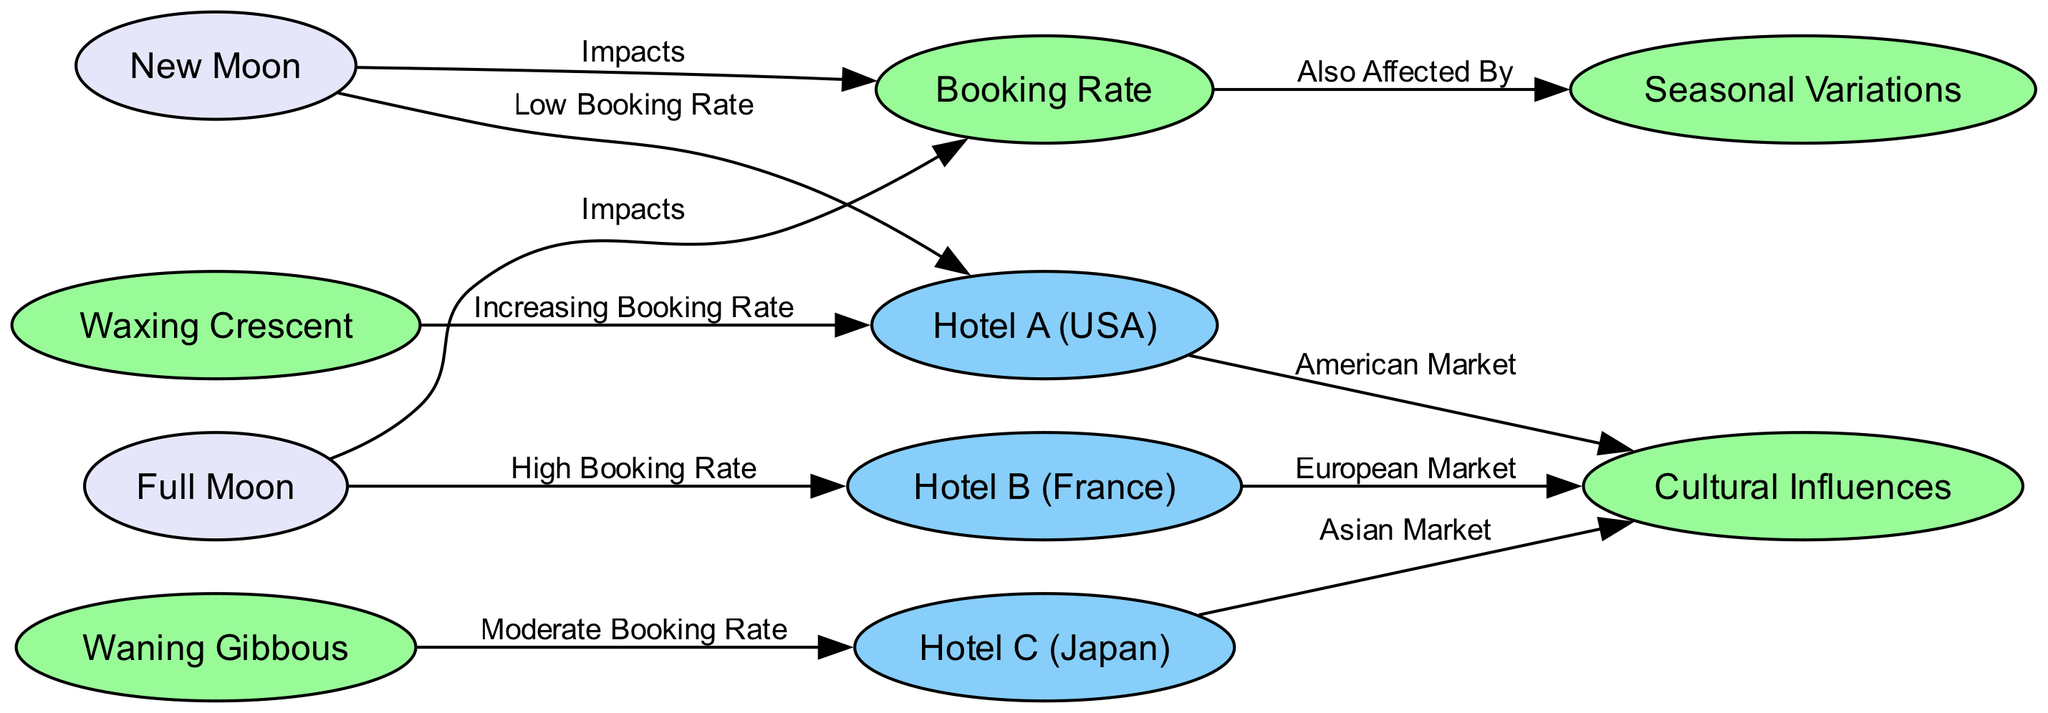What is the booking rate during the full moon for Hotel B? The diagram shows an edge from full moon to Hotel B labeled "High Booking Rate," indicating that the booking rate is high during the full moon specifically for Hotel B.
Answer: High Booking Rate Which hotel experiences a low booking rate during the new moon? The diagram has a direct connection from new moon to Hotel A labeled "Low Booking Rate," which specifies that Hotel A is impacted negatively by the new moon.
Answer: Hotel A How many nodes are related to cultural influences in the diagram? Observing the diagram, three hotels have edges connecting to the node "Cultural Influences," indicating the cultural impact on each hotel's market. Therefore, there are three nodes related to cultural influences.
Answer: 3 What lunar phase is associated with an increasing booking rate for Hotel A? The diagram indicates that there is an edge from waxing crescent to Hotel A labeled "Increasing Booking Rate," which shows that the waxing crescent moon correlates positively for Hotel A's bookings.
Answer: Waxing Crescent Which hotel corresponds to the Asian market? In the diagram, Hotel C has an edge to the node "Cultural Influences" labeled "Asian Market," clearly identifying Hotel C as the representative for the Asian market.
Answer: Hotel C What edge connects the new moon to the booking rate? The diagram displays an edge from new moon to booking rate labeled "Impacts," which describes the influence that the new moon has on the overall booking rate.
Answer: Impacts Which cultural market is associated with Hotel B? The connection from Hotel B to "Cultural Influences" is labeled "European Market," indicating that Hotel B specifically targets or reflects the European cultural market.
Answer: European Market What kind of booking rate does Hotel C see during the waning gibbous phase? The edge from waning gibbous to Hotel C is labeled "Moderate Booking Rate," which suggests that bookings at Hotel C are moderate during this lunar phase.
Answer: Moderate Booking Rate 